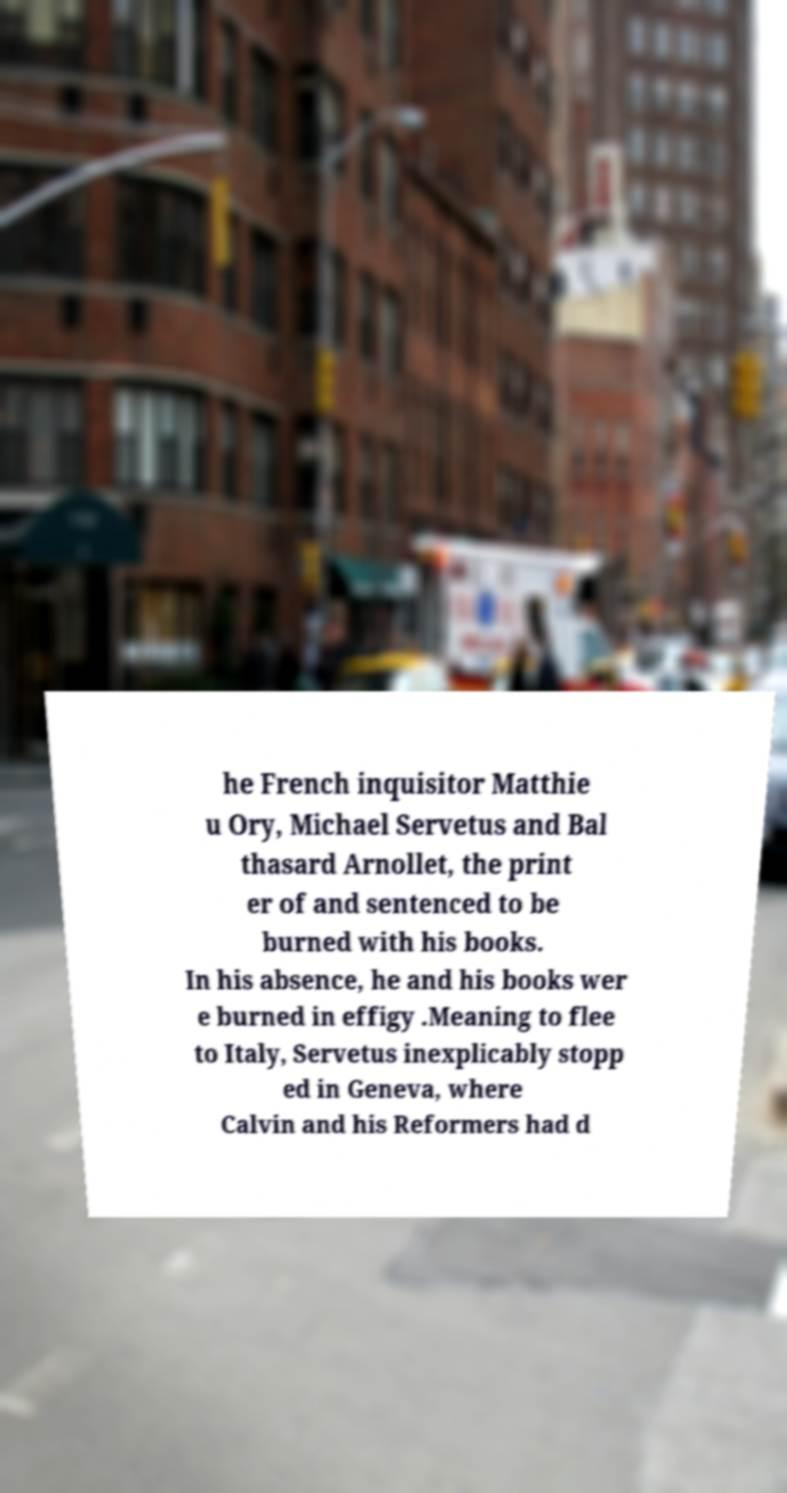Could you extract and type out the text from this image? he French inquisitor Matthie u Ory, Michael Servetus and Bal thasard Arnollet, the print er of and sentenced to be burned with his books. In his absence, he and his books wer e burned in effigy .Meaning to flee to Italy, Servetus inexplicably stopp ed in Geneva, where Calvin and his Reformers had d 